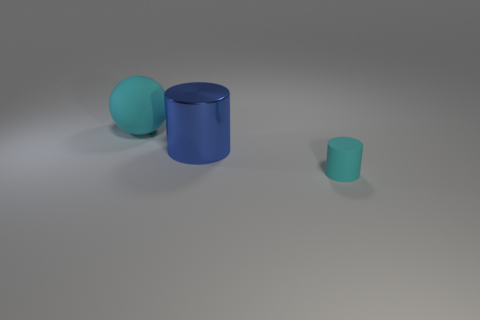There is another thing that is the same size as the blue metallic object; what shape is it?
Make the answer very short. Sphere. Is there a big thing that has the same color as the ball?
Ensure brevity in your answer.  No. There is a big shiny cylinder; is its color the same as the rubber thing that is on the left side of the tiny cyan cylinder?
Give a very brief answer. No. There is a big object behind the large thing on the right side of the large cyan rubber ball; what color is it?
Offer a terse response. Cyan. Are there any cyan spheres behind the matte object that is behind the cylinder to the right of the blue object?
Your answer should be very brief. No. There is a tiny cylinder that is made of the same material as the sphere; what color is it?
Offer a very short reply. Cyan. How many other cylinders have the same material as the blue cylinder?
Your answer should be compact. 0. Is the large blue thing made of the same material as the cyan object that is behind the tiny object?
Make the answer very short. No. What number of things are large things to the left of the metal cylinder or large cyan rubber things?
Give a very brief answer. 1. There is a object to the right of the cylinder that is behind the object that is in front of the large cylinder; what size is it?
Ensure brevity in your answer.  Small. 